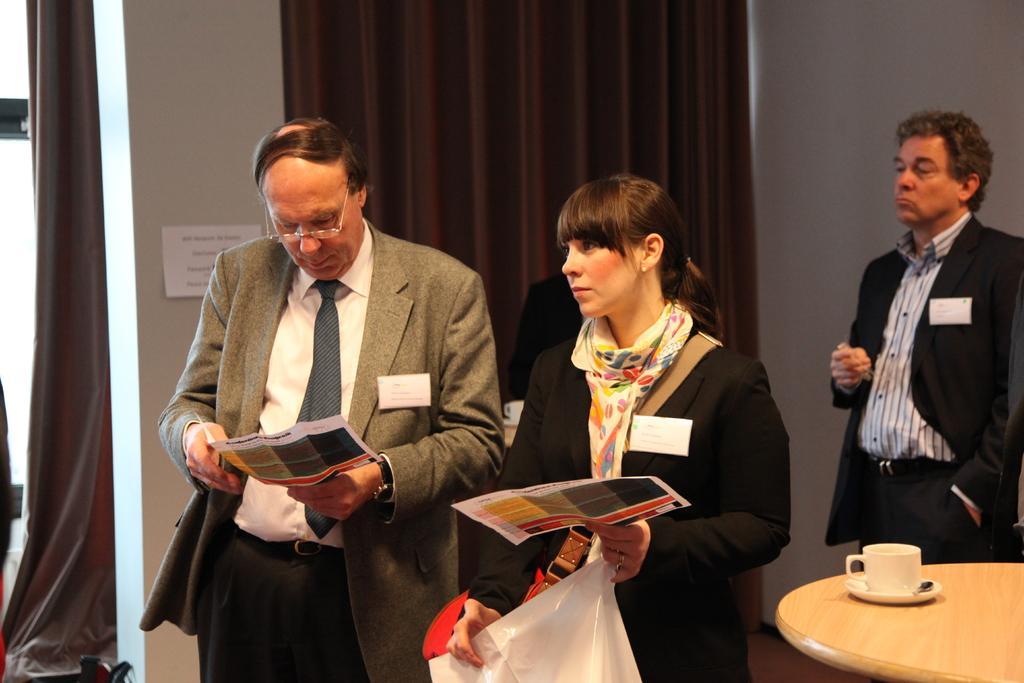How would you summarize this image in a sentence or two? In the center of the image we can see persons standing on the floor with papers. In the background we can see wall, curtains, persons. On the right side of the image we can see person, table, cup and saucer. 